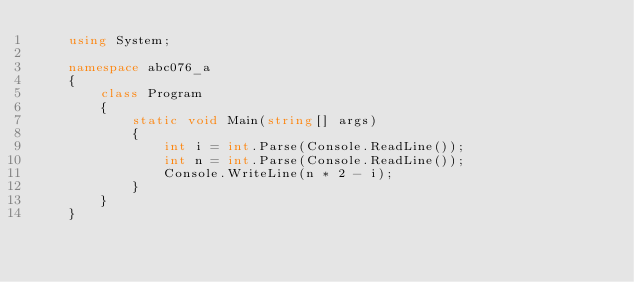<code> <loc_0><loc_0><loc_500><loc_500><_C#_>    using System;
     
    namespace abc076_a
    {
        class Program
        {
            static void Main(string[] args)
            {
                int i = int.Parse(Console.ReadLine());
                int n = int.Parse(Console.ReadLine());
                Console.WriteLine(n * 2 - i);
            }
        }
    }</code> 